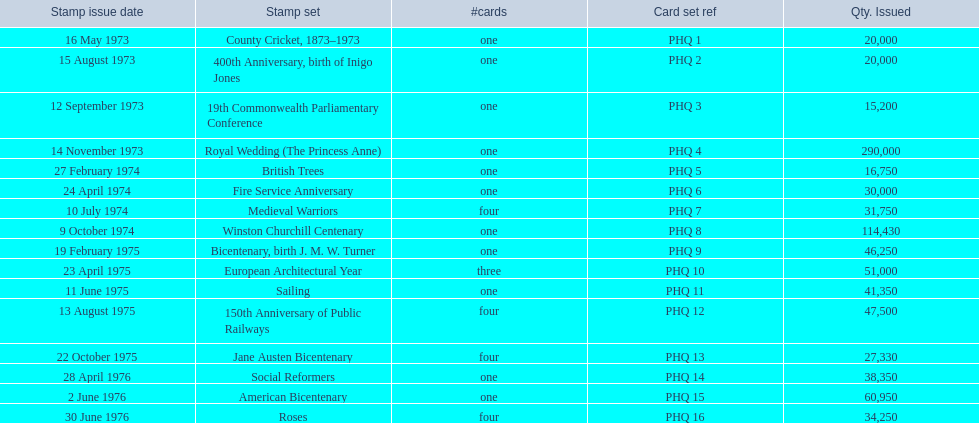In which stamp sets can more than one card be found? Medieval Warriors, European Architectural Year, 150th Anniversary of Public Railways, Jane Austen Bicentenary, Roses. From those sets, which has an exclusive number of cards? European Architectural Year. 